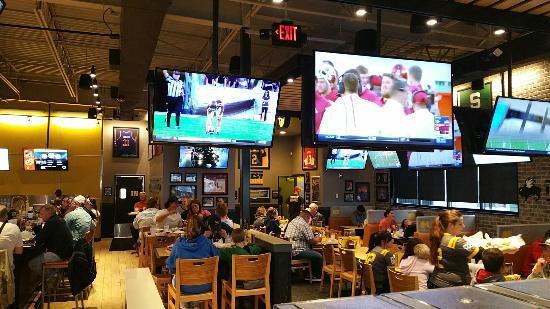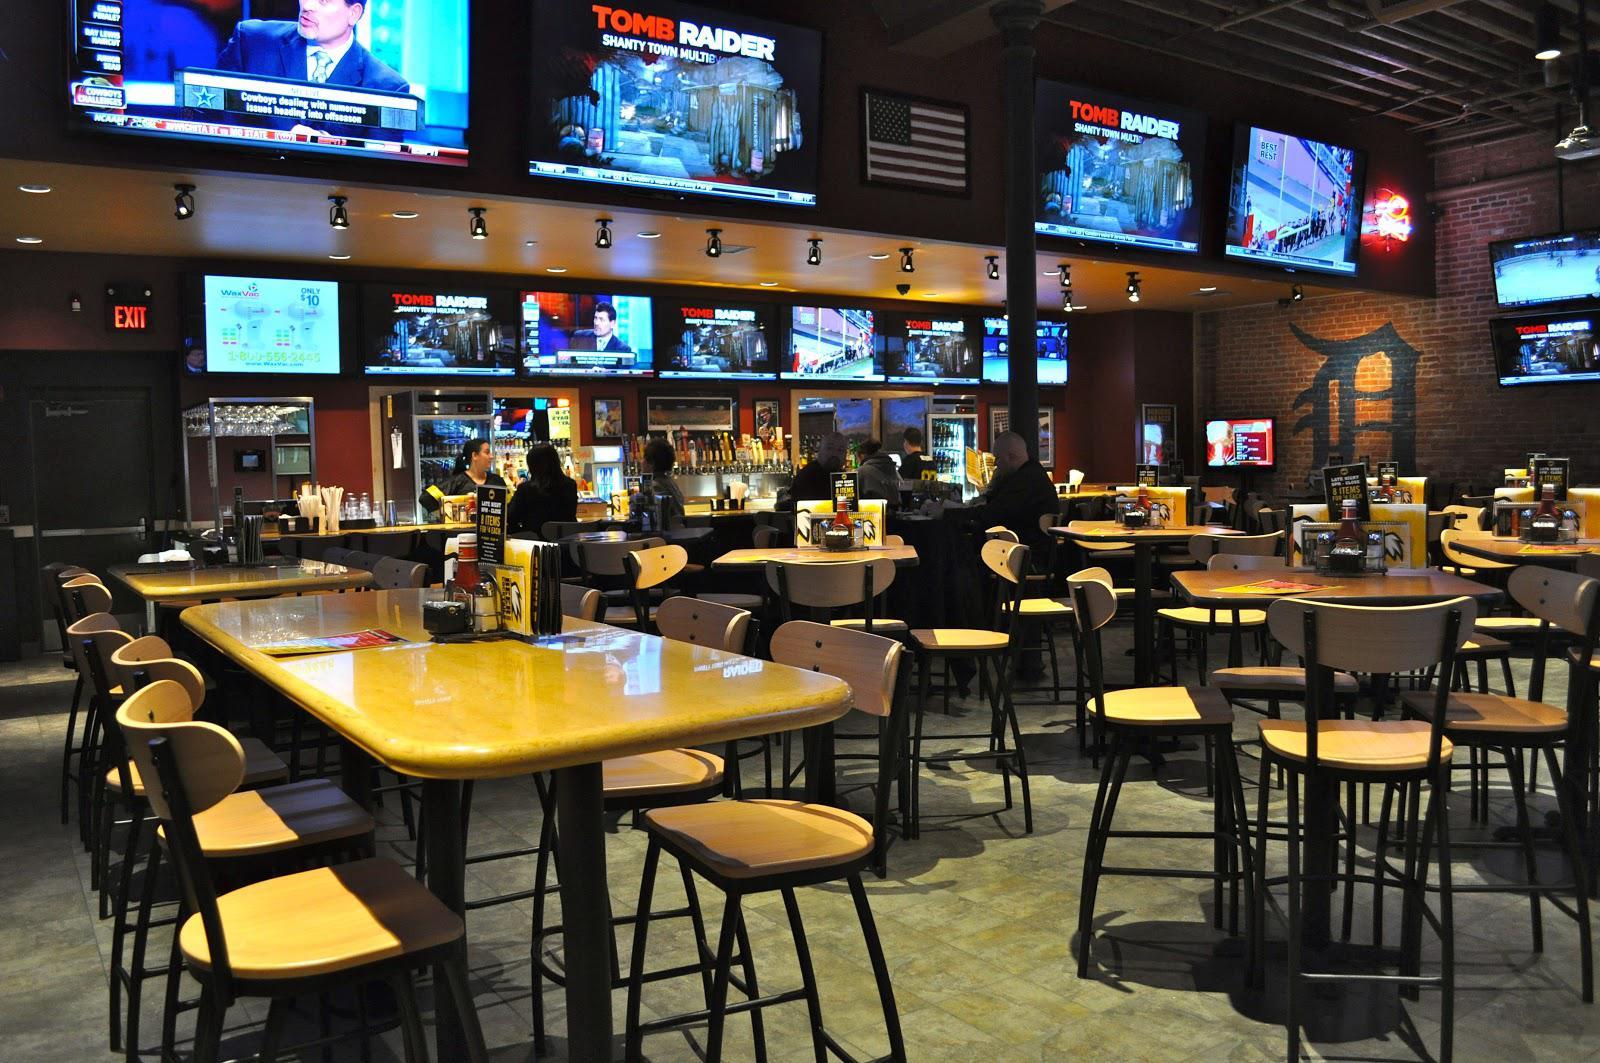The first image is the image on the left, the second image is the image on the right. Considering the images on both sides, is "There are no people in either image." valid? Answer yes or no. No. 